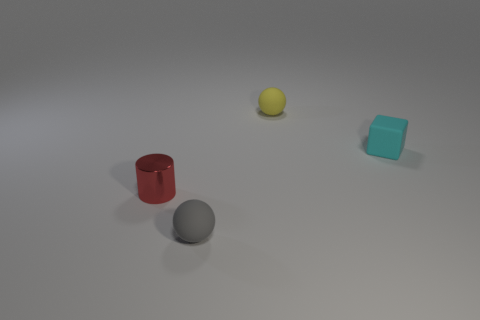Is the size of the red cylinder the same as the gray sphere?
Make the answer very short. Yes. What number of balls are either small matte objects or small cyan matte things?
Give a very brief answer. 2. What number of other objects are the same shape as the tiny gray object?
Your answer should be compact. 1. Are there more tiny things in front of the yellow matte ball than tiny blocks that are on the left side of the small cyan cube?
Your answer should be very brief. Yes. The cyan cube has what size?
Keep it short and to the point. Small. What material is the cyan block that is the same size as the gray rubber ball?
Your response must be concise. Rubber. There is a matte sphere that is right of the gray object; what is its color?
Ensure brevity in your answer.  Yellow. How many tiny yellow matte objects are there?
Provide a succinct answer. 1. There is a tiny rubber thing that is to the left of the sphere that is behind the cylinder; is there a small red cylinder behind it?
Give a very brief answer. Yes. The shiny thing that is the same size as the gray sphere is what shape?
Provide a succinct answer. Cylinder. 